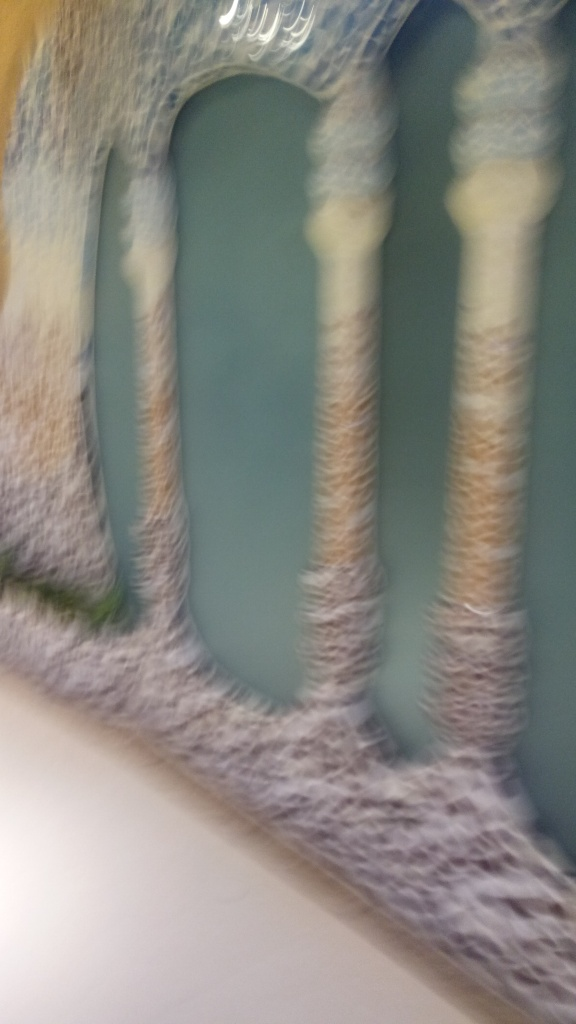Despite the blur, can you infer what the subject of the photograph might be? While the specifics are indistinct, the image appears to show a structure with columns, suggesting an architectural subject, possibly the interior of a building or a facade. The repetition of vertical lines and shapes alludes to a design element, typical for stylized structures like doorways, halls, or windows. 